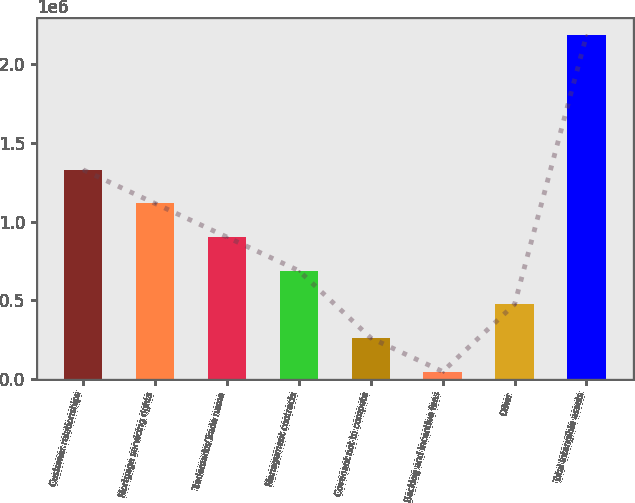Convert chart. <chart><loc_0><loc_0><loc_500><loc_500><bar_chart><fcel>Customer relationships<fcel>Mortgage servicing rights<fcel>Trademarks/Trade name<fcel>Management contracts<fcel>Covenant not to compete<fcel>Backlog and incentive fees<fcel>Other<fcel>Total intangible assets<nl><fcel>1.32901e+06<fcel>1.11558e+06<fcel>902152<fcel>688725<fcel>261872<fcel>48445<fcel>475298<fcel>2.18271e+06<nl></chart> 